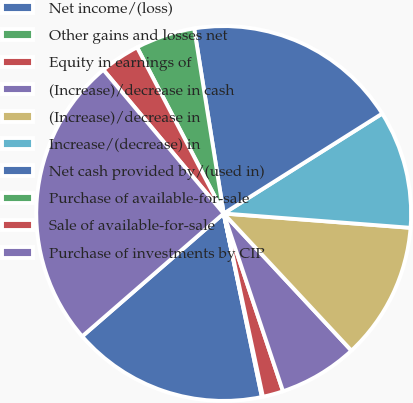<chart> <loc_0><loc_0><loc_500><loc_500><pie_chart><fcel>Net income/(loss)<fcel>Other gains and losses net<fcel>Equity in earnings of<fcel>(Increase)/decrease in cash<fcel>(Increase)/decrease in<fcel>Increase/(decrease) in<fcel>Net cash provided by/(used in)<fcel>Purchase of available-for-sale<fcel>Sale of available-for-sale<fcel>Purchase of investments by CIP<nl><fcel>16.89%<fcel>0.09%<fcel>1.77%<fcel>6.81%<fcel>11.85%<fcel>10.17%<fcel>18.57%<fcel>5.13%<fcel>3.45%<fcel>25.29%<nl></chart> 